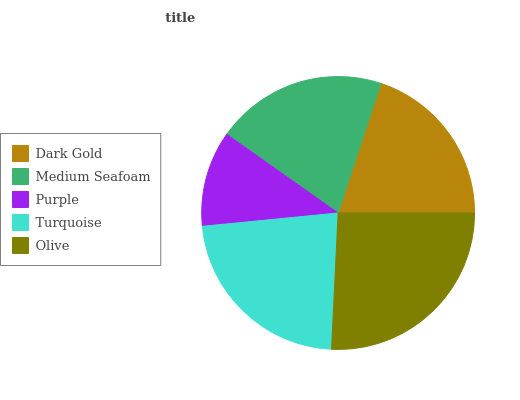Is Purple the minimum?
Answer yes or no. Yes. Is Olive the maximum?
Answer yes or no. Yes. Is Medium Seafoam the minimum?
Answer yes or no. No. Is Medium Seafoam the maximum?
Answer yes or no. No. Is Medium Seafoam greater than Dark Gold?
Answer yes or no. Yes. Is Dark Gold less than Medium Seafoam?
Answer yes or no. Yes. Is Dark Gold greater than Medium Seafoam?
Answer yes or no. No. Is Medium Seafoam less than Dark Gold?
Answer yes or no. No. Is Medium Seafoam the high median?
Answer yes or no. Yes. Is Medium Seafoam the low median?
Answer yes or no. Yes. Is Dark Gold the high median?
Answer yes or no. No. Is Purple the low median?
Answer yes or no. No. 